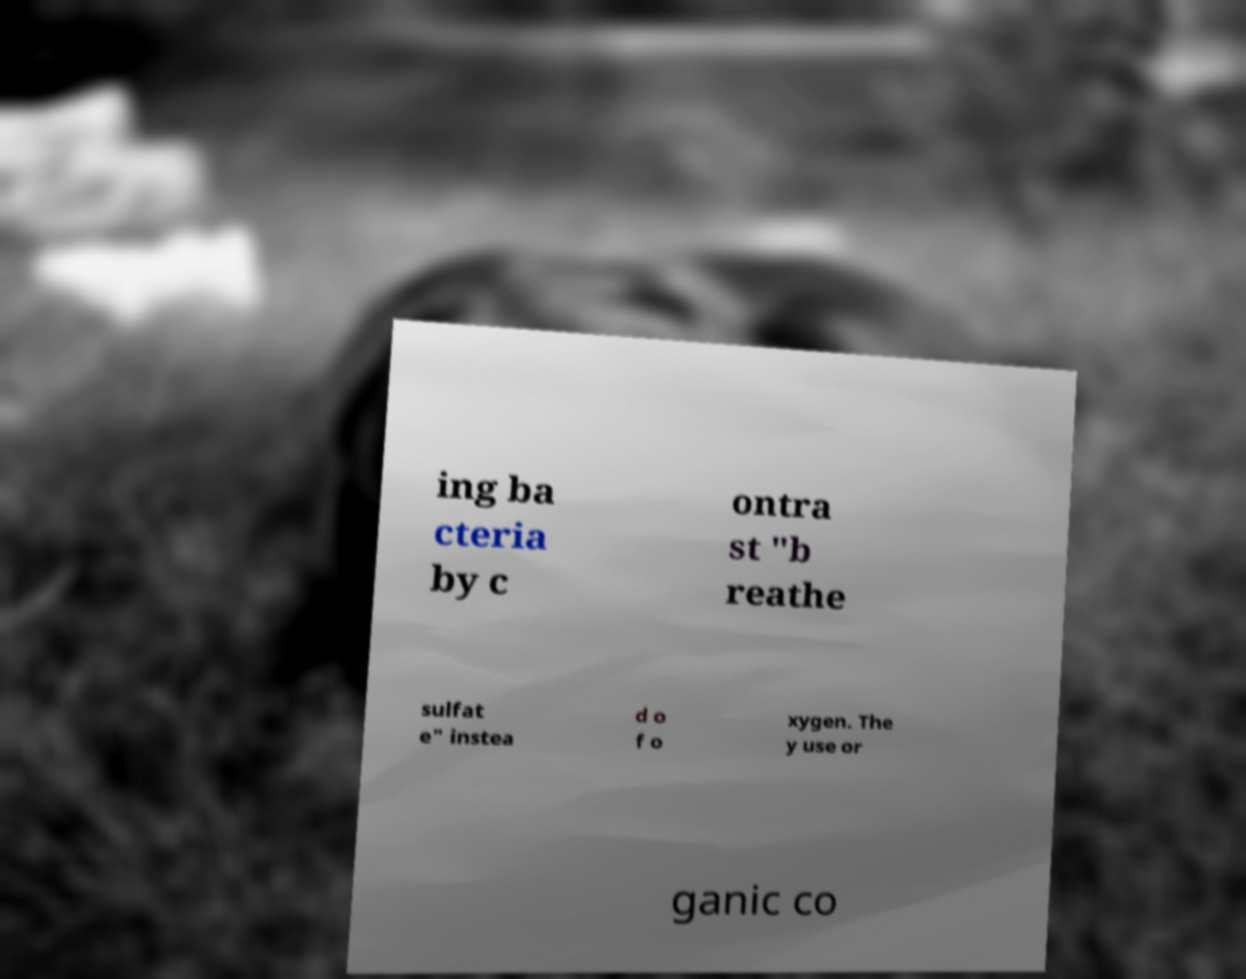For documentation purposes, I need the text within this image transcribed. Could you provide that? ing ba cteria by c ontra st "b reathe sulfat e" instea d o f o xygen. The y use or ganic co 